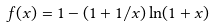<formula> <loc_0><loc_0><loc_500><loc_500>f ( x ) = 1 - ( 1 + 1 / x ) \ln ( 1 + x )</formula> 